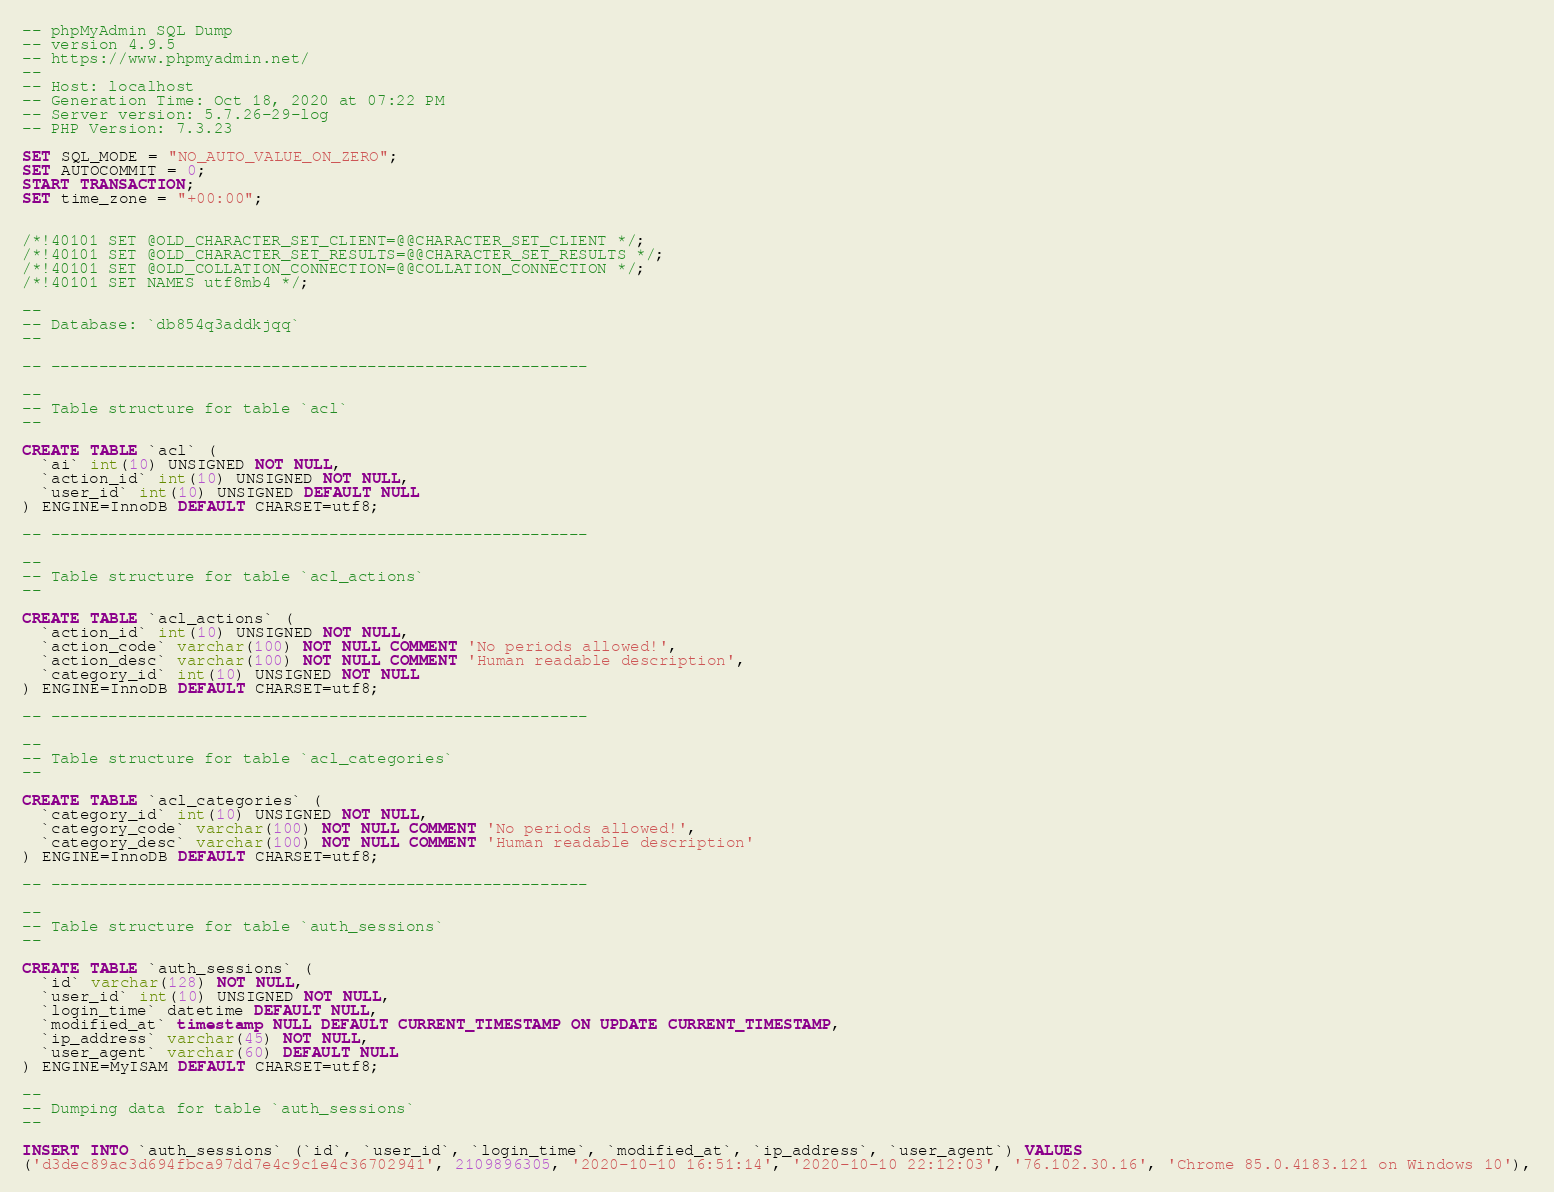<code> <loc_0><loc_0><loc_500><loc_500><_SQL_>-- phpMyAdmin SQL Dump
-- version 4.9.5
-- https://www.phpmyadmin.net/
--
-- Host: localhost
-- Generation Time: Oct 18, 2020 at 07:22 PM
-- Server version: 5.7.26-29-log
-- PHP Version: 7.3.23

SET SQL_MODE = "NO_AUTO_VALUE_ON_ZERO";
SET AUTOCOMMIT = 0;
START TRANSACTION;
SET time_zone = "+00:00";


/*!40101 SET @OLD_CHARACTER_SET_CLIENT=@@CHARACTER_SET_CLIENT */;
/*!40101 SET @OLD_CHARACTER_SET_RESULTS=@@CHARACTER_SET_RESULTS */;
/*!40101 SET @OLD_COLLATION_CONNECTION=@@COLLATION_CONNECTION */;
/*!40101 SET NAMES utf8mb4 */;

--
-- Database: `db854q3addkjqq`
--

-- --------------------------------------------------------

--
-- Table structure for table `acl`
--

CREATE TABLE `acl` (
  `ai` int(10) UNSIGNED NOT NULL,
  `action_id` int(10) UNSIGNED NOT NULL,
  `user_id` int(10) UNSIGNED DEFAULT NULL
) ENGINE=InnoDB DEFAULT CHARSET=utf8;

-- --------------------------------------------------------

--
-- Table structure for table `acl_actions`
--

CREATE TABLE `acl_actions` (
  `action_id` int(10) UNSIGNED NOT NULL,
  `action_code` varchar(100) NOT NULL COMMENT 'No periods allowed!',
  `action_desc` varchar(100) NOT NULL COMMENT 'Human readable description',
  `category_id` int(10) UNSIGNED NOT NULL
) ENGINE=InnoDB DEFAULT CHARSET=utf8;

-- --------------------------------------------------------

--
-- Table structure for table `acl_categories`
--

CREATE TABLE `acl_categories` (
  `category_id` int(10) UNSIGNED NOT NULL,
  `category_code` varchar(100) NOT NULL COMMENT 'No periods allowed!',
  `category_desc` varchar(100) NOT NULL COMMENT 'Human readable description'
) ENGINE=InnoDB DEFAULT CHARSET=utf8;

-- --------------------------------------------------------

--
-- Table structure for table `auth_sessions`
--

CREATE TABLE `auth_sessions` (
  `id` varchar(128) NOT NULL,
  `user_id` int(10) UNSIGNED NOT NULL,
  `login_time` datetime DEFAULT NULL,
  `modified_at` timestamp NULL DEFAULT CURRENT_TIMESTAMP ON UPDATE CURRENT_TIMESTAMP,
  `ip_address` varchar(45) NOT NULL,
  `user_agent` varchar(60) DEFAULT NULL
) ENGINE=MyISAM DEFAULT CHARSET=utf8;

--
-- Dumping data for table `auth_sessions`
--

INSERT INTO `auth_sessions` (`id`, `user_id`, `login_time`, `modified_at`, `ip_address`, `user_agent`) VALUES
('d3dec89ac3d694fbca97dd7e4c9c1e4c36702941', 2109896305, '2020-10-10 16:51:14', '2020-10-10 22:12:03', '76.102.30.16', 'Chrome 85.0.4183.121 on Windows 10'),</code> 